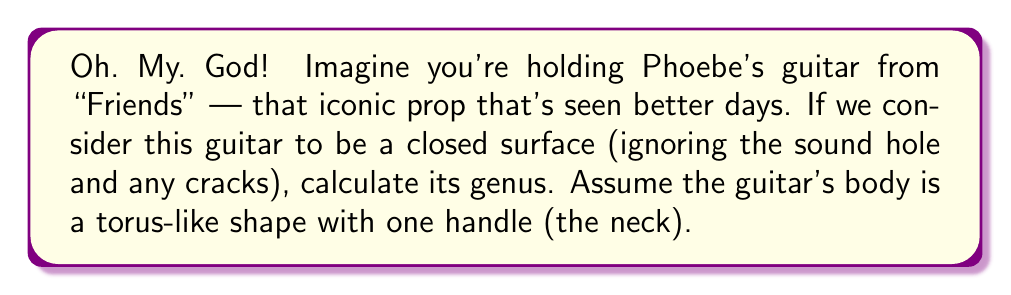Can you answer this question? Let's break this down step-by-step, keeping in mind that this news might be as shocking as Rachel and Ross's Vegas wedding:

1) In topology, the genus of a surface is the number of "holes" or "handles" it has. It's like counting how many coffee cup handles you can add to a shape without puncturing it.

2) A guitar's basic shape can be simplified topologically into two main parts:
   a) The body: This is essentially a hollow chamber, which topologically is equivalent to a torus (donut shape).
   b) The neck: This acts as an additional handle attached to the body.

3) A torus has a genus of 1. This is because it has one hole (the center of the donut).

4) The neck of the guitar adds another "handle" to this torus.

5) In topology, adding a handle increases the genus by 1.

6) Therefore, the total genus is:
   $$\text{Genus} = \text{Genus of body} + \text{Number of additional handles}$$
   $$\text{Genus} = 1 + 1 = 2$$

This result might be as surprising as finding out that Ugly Naked Guy was actually a character on the show!
Answer: The genus of the surface is 2. 